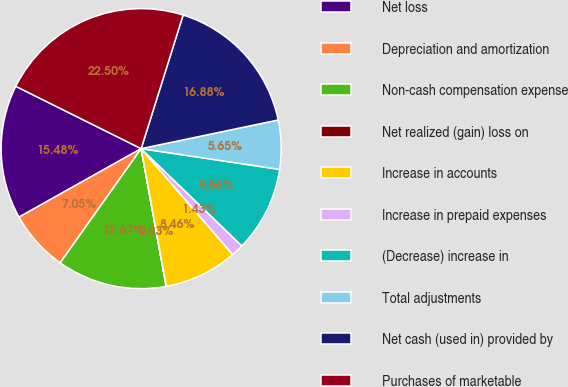Convert chart to OTSL. <chart><loc_0><loc_0><loc_500><loc_500><pie_chart><fcel>Net loss<fcel>Depreciation and amortization<fcel>Non-cash compensation expense<fcel>Net realized (gain) loss on<fcel>Increase in accounts<fcel>Increase in prepaid expenses<fcel>(Decrease) increase in<fcel>Total adjustments<fcel>Net cash (used in) provided by<fcel>Purchases of marketable<nl><fcel>15.48%<fcel>7.05%<fcel>12.67%<fcel>0.03%<fcel>8.46%<fcel>1.43%<fcel>9.86%<fcel>5.65%<fcel>16.88%<fcel>22.5%<nl></chart> 